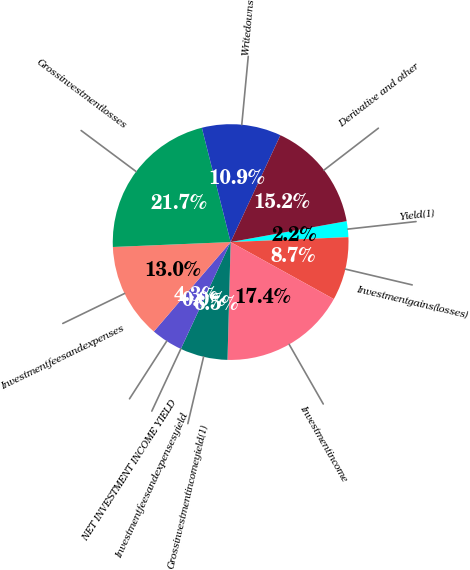Convert chart. <chart><loc_0><loc_0><loc_500><loc_500><pie_chart><fcel>Yield(1)<fcel>Investmentgains(losses)<fcel>Investmentincome<fcel>Grossinvestmentincomeyield(1)<fcel>Investmentfeesandexpensesyield<fcel>NET INVESTMENT INCOME YIELD<fcel>Investmentfeesandexpenses<fcel>Grossinvestmentlosses<fcel>Writedowns<fcel>Derivative and other<nl><fcel>2.18%<fcel>8.7%<fcel>17.39%<fcel>6.52%<fcel>0.0%<fcel>4.35%<fcel>13.04%<fcel>21.74%<fcel>10.87%<fcel>15.22%<nl></chart> 